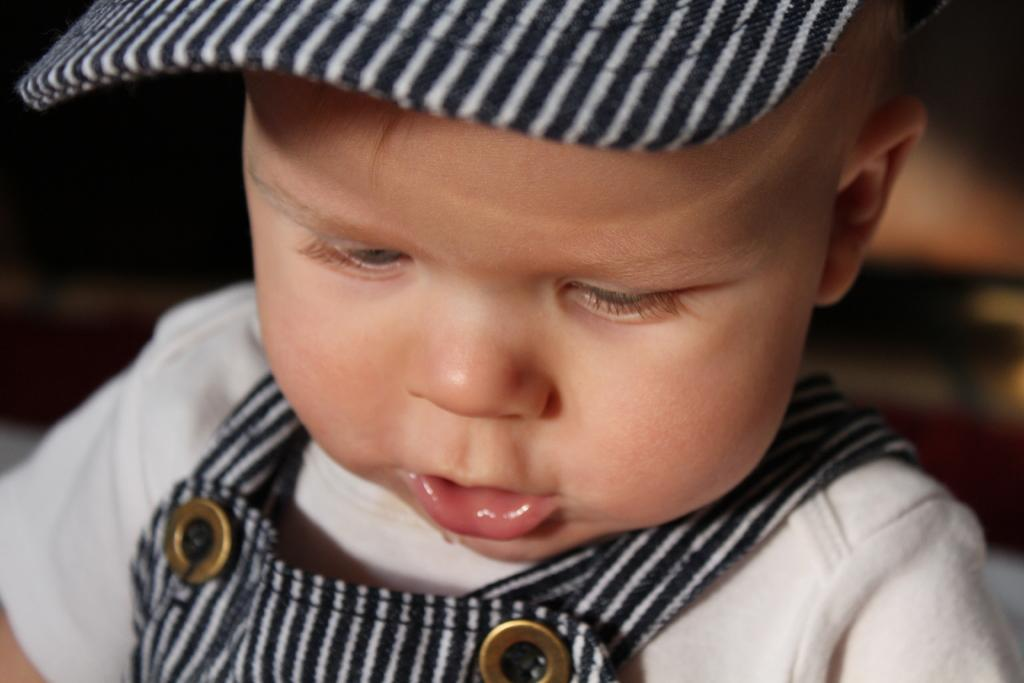What is the main subject of the image? The main subject of the image is a baby. What is the baby wearing on their head? The baby is wearing a black and white cap. What color is the baby's t-shirt? The baby is wearing a white t-shirt. What type of clothing is the baby wearing on their lower body? The baby is wearing a black and white dungaree. Is the baby's mother present in the image? There is no information provided about the baby's mother, so we cannot determine if she is present in the image. What type of cloth is the baby using to wipe their face? There is no cloth visible in the image, and the baby is not shown wiping their face. 